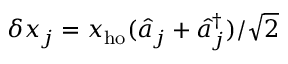<formula> <loc_0><loc_0><loc_500><loc_500>\delta x _ { j } = x _ { h o } ( \hat { a } _ { j } + \hat { a } _ { j } ^ { \dagger } ) / \sqrt { 2 }</formula> 